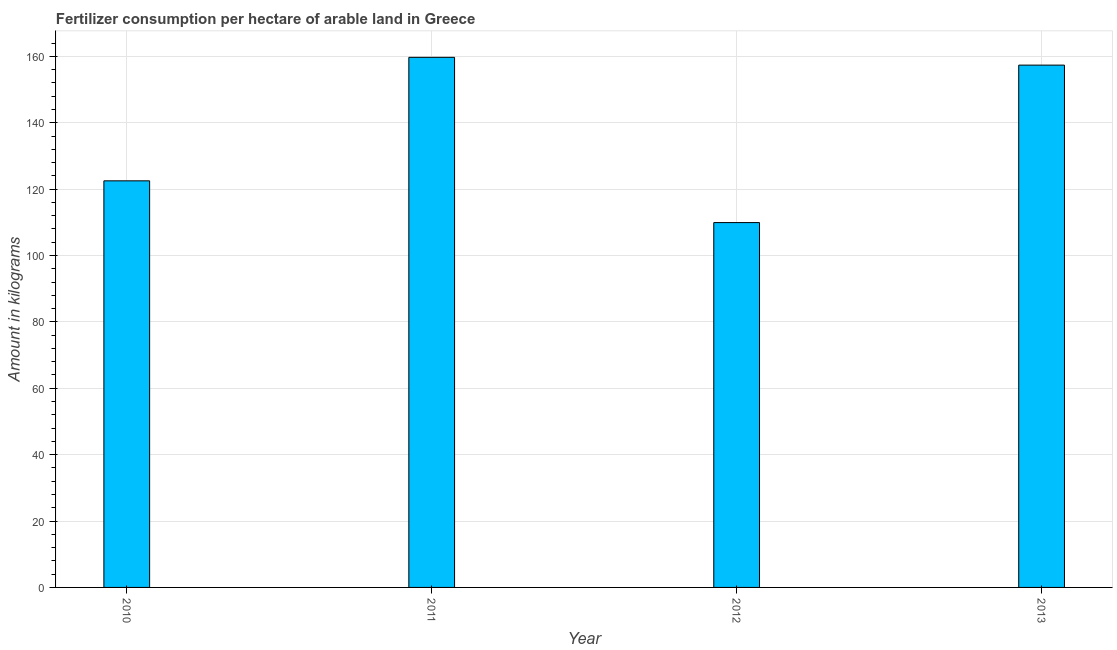What is the title of the graph?
Offer a terse response. Fertilizer consumption per hectare of arable land in Greece . What is the label or title of the X-axis?
Give a very brief answer. Year. What is the label or title of the Y-axis?
Give a very brief answer. Amount in kilograms. What is the amount of fertilizer consumption in 2010?
Your response must be concise. 122.5. Across all years, what is the maximum amount of fertilizer consumption?
Give a very brief answer. 159.71. Across all years, what is the minimum amount of fertilizer consumption?
Your response must be concise. 109.92. In which year was the amount of fertilizer consumption maximum?
Provide a succinct answer. 2011. In which year was the amount of fertilizer consumption minimum?
Your answer should be very brief. 2012. What is the sum of the amount of fertilizer consumption?
Make the answer very short. 549.49. What is the difference between the amount of fertilizer consumption in 2010 and 2012?
Keep it short and to the point. 12.58. What is the average amount of fertilizer consumption per year?
Your answer should be very brief. 137.37. What is the median amount of fertilizer consumption?
Provide a short and direct response. 139.93. Do a majority of the years between 2010 and 2013 (inclusive) have amount of fertilizer consumption greater than 132 kg?
Provide a short and direct response. No. What is the ratio of the amount of fertilizer consumption in 2011 to that in 2013?
Provide a succinct answer. 1.01. Is the amount of fertilizer consumption in 2010 less than that in 2012?
Keep it short and to the point. No. Is the difference between the amount of fertilizer consumption in 2010 and 2011 greater than the difference between any two years?
Offer a very short reply. No. What is the difference between the highest and the second highest amount of fertilizer consumption?
Keep it short and to the point. 2.34. What is the difference between the highest and the lowest amount of fertilizer consumption?
Your answer should be very brief. 49.79. In how many years, is the amount of fertilizer consumption greater than the average amount of fertilizer consumption taken over all years?
Ensure brevity in your answer.  2. What is the difference between two consecutive major ticks on the Y-axis?
Give a very brief answer. 20. Are the values on the major ticks of Y-axis written in scientific E-notation?
Ensure brevity in your answer.  No. What is the Amount in kilograms in 2010?
Your answer should be compact. 122.5. What is the Amount in kilograms in 2011?
Provide a short and direct response. 159.71. What is the Amount in kilograms of 2012?
Offer a terse response. 109.92. What is the Amount in kilograms of 2013?
Ensure brevity in your answer.  157.36. What is the difference between the Amount in kilograms in 2010 and 2011?
Ensure brevity in your answer.  -37.21. What is the difference between the Amount in kilograms in 2010 and 2012?
Your response must be concise. 12.58. What is the difference between the Amount in kilograms in 2010 and 2013?
Give a very brief answer. -34.87. What is the difference between the Amount in kilograms in 2011 and 2012?
Offer a terse response. 49.79. What is the difference between the Amount in kilograms in 2011 and 2013?
Provide a short and direct response. 2.34. What is the difference between the Amount in kilograms in 2012 and 2013?
Offer a terse response. -47.44. What is the ratio of the Amount in kilograms in 2010 to that in 2011?
Provide a short and direct response. 0.77. What is the ratio of the Amount in kilograms in 2010 to that in 2012?
Give a very brief answer. 1.11. What is the ratio of the Amount in kilograms in 2010 to that in 2013?
Offer a terse response. 0.78. What is the ratio of the Amount in kilograms in 2011 to that in 2012?
Give a very brief answer. 1.45. What is the ratio of the Amount in kilograms in 2012 to that in 2013?
Give a very brief answer. 0.7. 